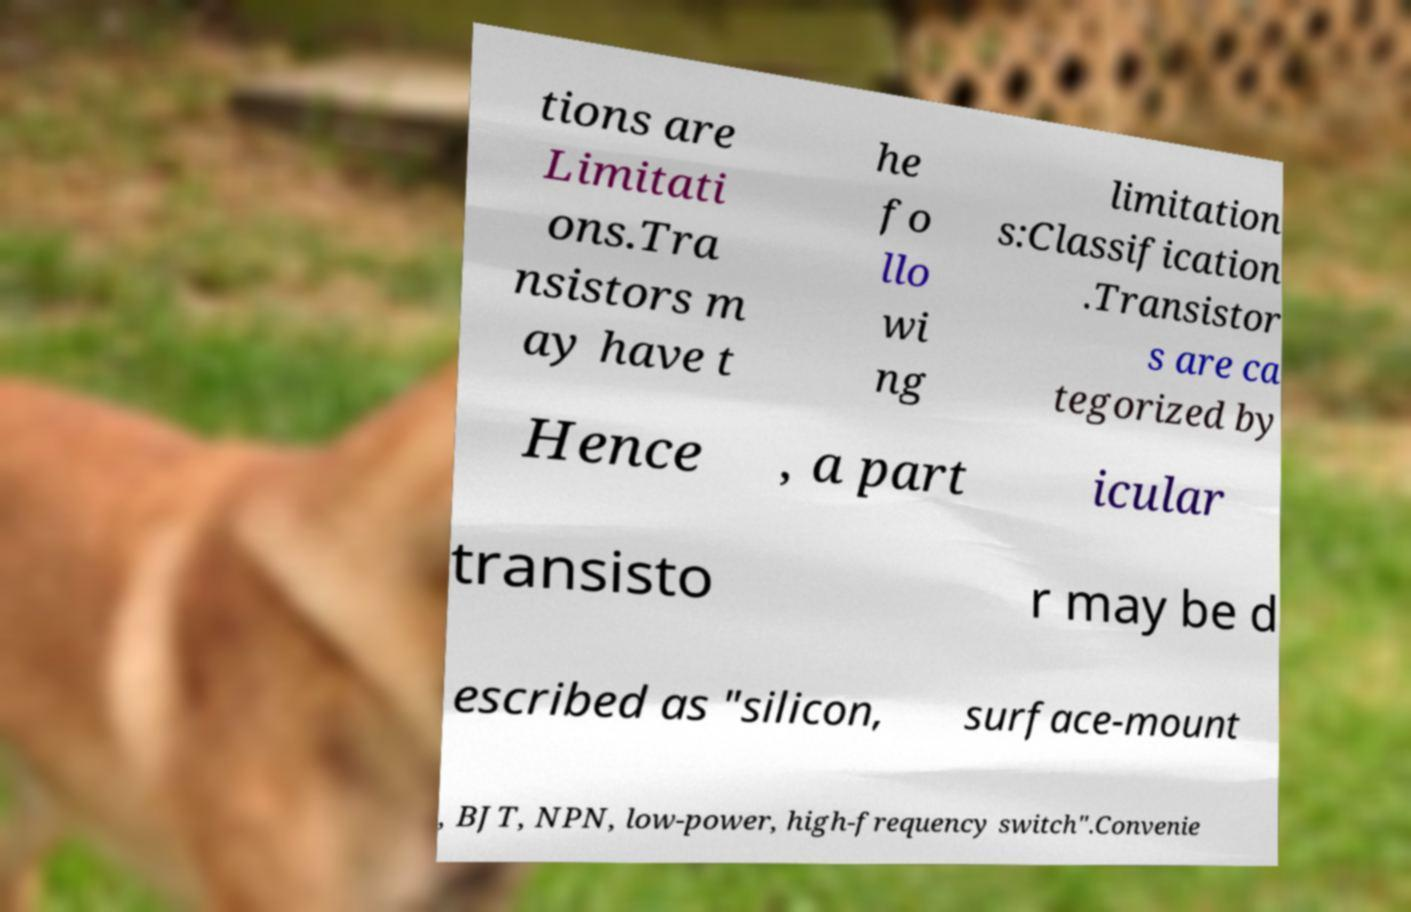Could you assist in decoding the text presented in this image and type it out clearly? tions are Limitati ons.Tra nsistors m ay have t he fo llo wi ng limitation s:Classification .Transistor s are ca tegorized by Hence , a part icular transisto r may be d escribed as "silicon, surface-mount , BJT, NPN, low-power, high-frequency switch".Convenie 